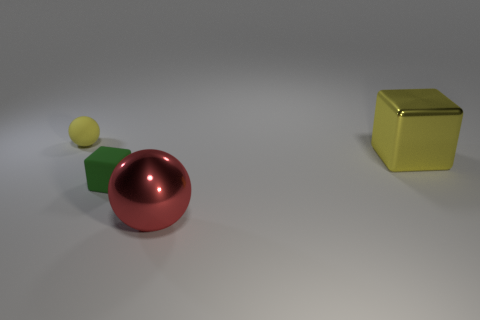Add 3 red things. How many objects exist? 7 Subtract 1 blocks. How many blocks are left? 1 Add 3 large metallic balls. How many large metallic balls are left? 4 Add 4 large yellow metal things. How many large yellow metal things exist? 5 Subtract 0 purple cylinders. How many objects are left? 4 Subtract all brown cubes. Subtract all brown spheres. How many cubes are left? 2 Subtract all purple cylinders. How many brown cubes are left? 0 Subtract all tiny green objects. Subtract all small green matte cubes. How many objects are left? 2 